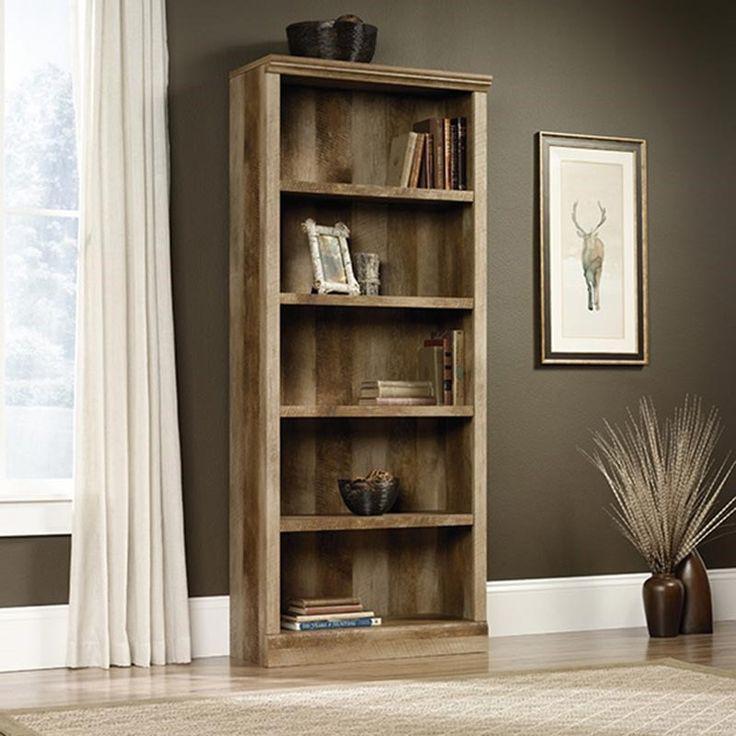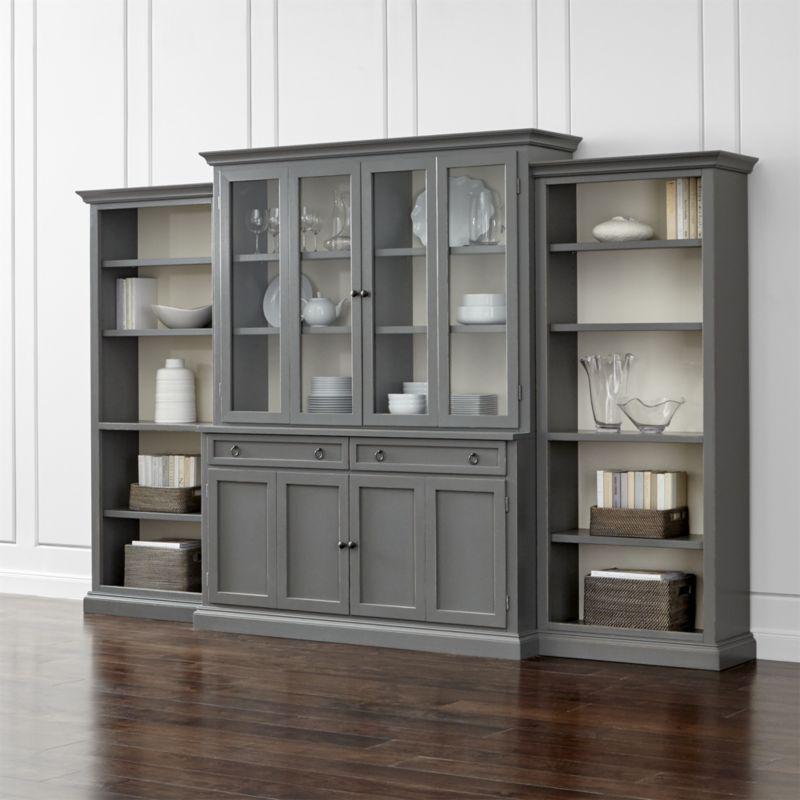The first image is the image on the left, the second image is the image on the right. Analyze the images presented: Is the assertion "Exactly one image contains potted flowers." valid? Answer yes or no. No. 